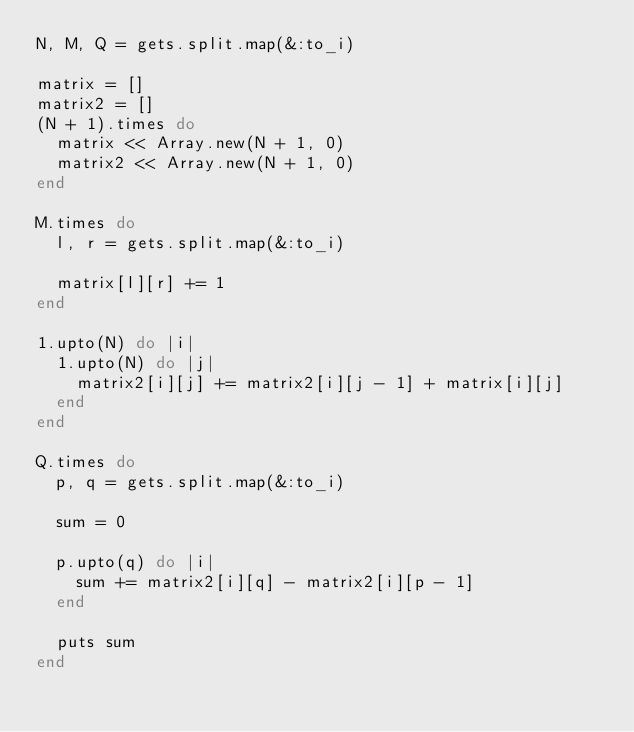Convert code to text. <code><loc_0><loc_0><loc_500><loc_500><_Ruby_>N, M, Q = gets.split.map(&:to_i)

matrix = []
matrix2 = []
(N + 1).times do
  matrix << Array.new(N + 1, 0)
  matrix2 << Array.new(N + 1, 0)
end

M.times do
  l, r = gets.split.map(&:to_i)

  matrix[l][r] += 1
end

1.upto(N) do |i|
  1.upto(N) do |j|
    matrix2[i][j] += matrix2[i][j - 1] + matrix[i][j]
  end
end

Q.times do
  p, q = gets.split.map(&:to_i)

  sum = 0

  p.upto(q) do |i|
    sum += matrix2[i][q] - matrix2[i][p - 1]
  end

  puts sum
end</code> 